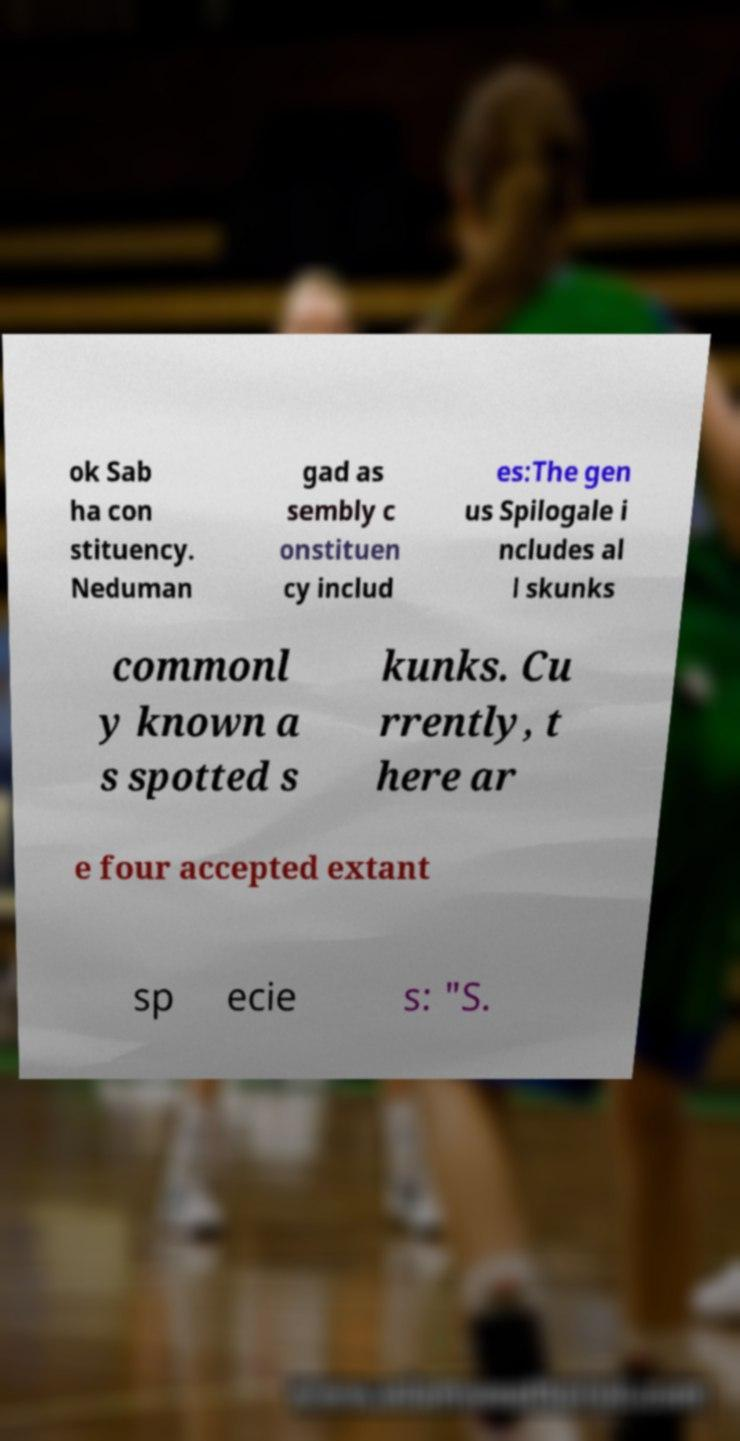There's text embedded in this image that I need extracted. Can you transcribe it verbatim? ok Sab ha con stituency. Neduman gad as sembly c onstituen cy includ es:The gen us Spilogale i ncludes al l skunks commonl y known a s spotted s kunks. Cu rrently, t here ar e four accepted extant sp ecie s: "S. 